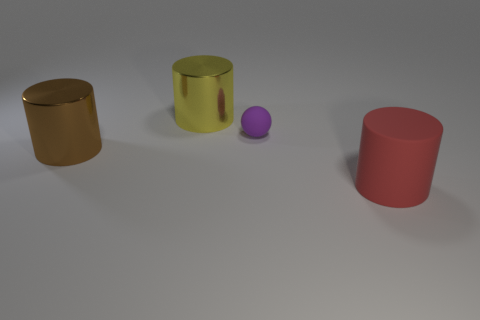Subtract all yellow metal cylinders. How many cylinders are left? 2 Subtract all brown cylinders. How many cylinders are left? 2 Add 3 big brown things. How many objects exist? 7 Subtract 1 balls. How many balls are left? 0 Add 3 big shiny objects. How many big shiny objects are left? 5 Add 3 brown metal objects. How many brown metal objects exist? 4 Subtract 0 cyan cylinders. How many objects are left? 4 Subtract all cylinders. How many objects are left? 1 Subtract all brown cylinders. Subtract all red balls. How many cylinders are left? 2 Subtract all blue cylinders. How many yellow spheres are left? 0 